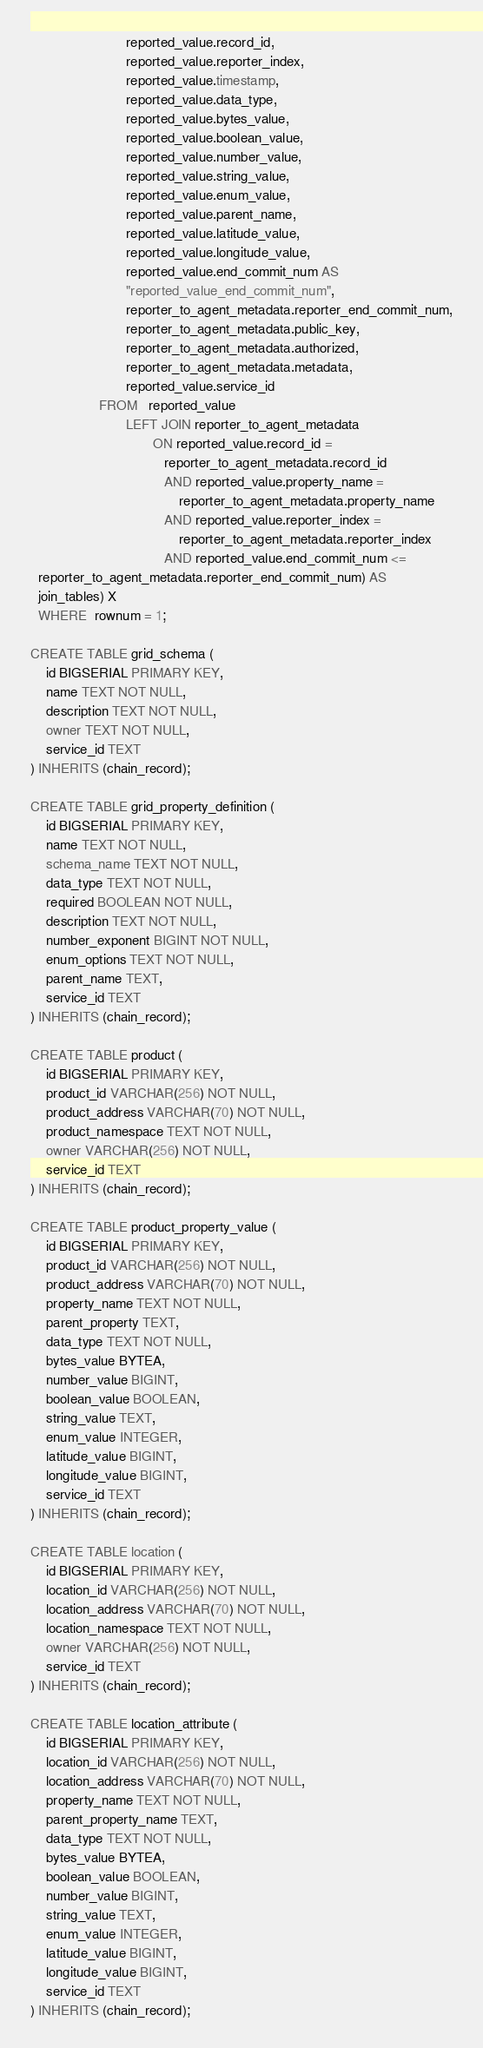<code> <loc_0><loc_0><loc_500><loc_500><_SQL_>                         reported_value.record_id,
                         reported_value.reporter_index,
                         reported_value.timestamp,
                         reported_value.data_type,
                         reported_value.bytes_value,
                         reported_value.boolean_value,
                         reported_value.number_value,
                         reported_value.string_value,
                         reported_value.enum_value,
                         reported_value.parent_name,
                         reported_value.latitude_value,
                         reported_value.longitude_value,
                         reported_value.end_commit_num AS
                         "reported_value_end_commit_num",
                         reporter_to_agent_metadata.reporter_end_commit_num,
                         reporter_to_agent_metadata.public_key,
                         reporter_to_agent_metadata.authorized,
                         reporter_to_agent_metadata.metadata,
                         reported_value.service_id
                  FROM   reported_value
                         LEFT JOIN reporter_to_agent_metadata
                                ON reported_value.record_id =
                                   reporter_to_agent_metadata.record_id
                                   AND reported_value.property_name =
                                       reporter_to_agent_metadata.property_name
                                   AND reported_value.reporter_index =
                                       reporter_to_agent_metadata.reporter_index
                                   AND reported_value.end_commit_num <=
  reporter_to_agent_metadata.reporter_end_commit_num) AS
  join_tables) X
  WHERE  rownum = 1;

CREATE TABLE grid_schema (
    id BIGSERIAL PRIMARY KEY,
    name TEXT NOT NULL,
    description TEXT NOT NULL,
    owner TEXT NOT NULL,
    service_id TEXT
) INHERITS (chain_record);

CREATE TABLE grid_property_definition (
    id BIGSERIAL PRIMARY KEY,
    name TEXT NOT NULL,
    schema_name TEXT NOT NULL,
    data_type TEXT NOT NULL,
    required BOOLEAN NOT NULL,
    description TEXT NOT NULL,
    number_exponent BIGINT NOT NULL,
    enum_options TEXT NOT NULL,
    parent_name TEXT,
    service_id TEXT
) INHERITS (chain_record);

CREATE TABLE product (
    id BIGSERIAL PRIMARY KEY,
    product_id VARCHAR(256) NOT NULL,
    product_address VARCHAR(70) NOT NULL,
    product_namespace TEXT NOT NULL,
    owner VARCHAR(256) NOT NULL,
    service_id TEXT
) INHERITS (chain_record);

CREATE TABLE product_property_value (
    id BIGSERIAL PRIMARY KEY,
    product_id VARCHAR(256) NOT NULL,
    product_address VARCHAR(70) NOT NULL,
    property_name TEXT NOT NULL,
    parent_property TEXT,
    data_type TEXT NOT NULL,
    bytes_value BYTEA,
    number_value BIGINT,
    boolean_value BOOLEAN,
    string_value TEXT,
    enum_value INTEGER,
    latitude_value BIGINT,
    longitude_value BIGINT,
    service_id TEXT
) INHERITS (chain_record);

CREATE TABLE location (
    id BIGSERIAL PRIMARY KEY,
    location_id VARCHAR(256) NOT NULL,
    location_address VARCHAR(70) NOT NULL,
    location_namespace TEXT NOT NULL,
    owner VARCHAR(256) NOT NULL,
    service_id TEXT
) INHERITS (chain_record);

CREATE TABLE location_attribute (
    id BIGSERIAL PRIMARY KEY,
    location_id VARCHAR(256) NOT NULL,
    location_address VARCHAR(70) NOT NULL,
    property_name TEXT NOT NULL,
    parent_property_name TEXT,
    data_type TEXT NOT NULL,
    bytes_value BYTEA,
    boolean_value BOOLEAN,
    number_value BIGINT,
    string_value TEXT,
    enum_value INTEGER,
    latitude_value BIGINT,
    longitude_value BIGINT,
    service_id TEXT
) INHERITS (chain_record);
</code> 